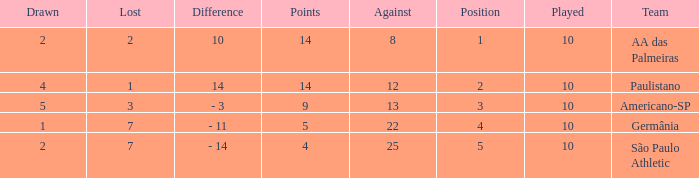What is the sum of Against when the lost is more than 7? None. 